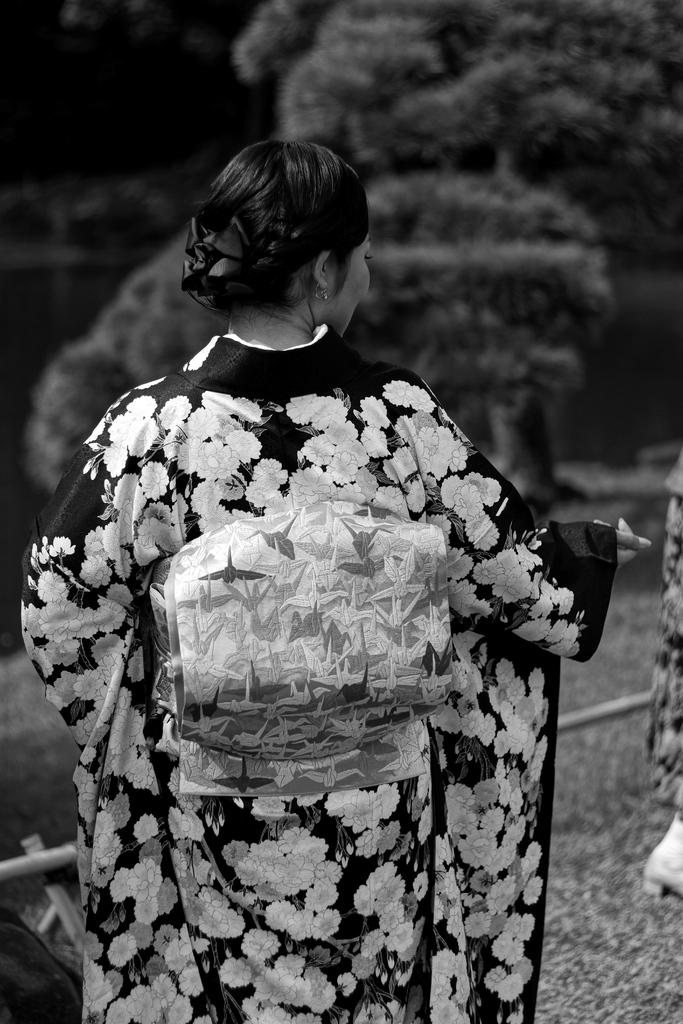Who is the main subject in the image? There is a woman standing in the front of the image. What can be seen in the background of the image? There are trees in the background of the image. What is the color scheme of the image? The image is black and white. What type of pump is being used by the committee in the image? There is no committee or pump present in the image; it features a woman standing in front of trees in a black and white image. 